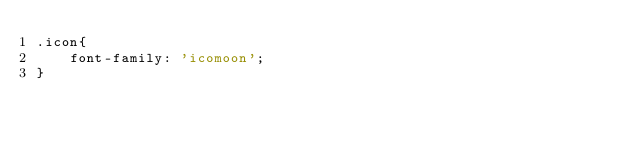<code> <loc_0><loc_0><loc_500><loc_500><_CSS_>.icon{
    font-family: 'icomoon';
}</code> 